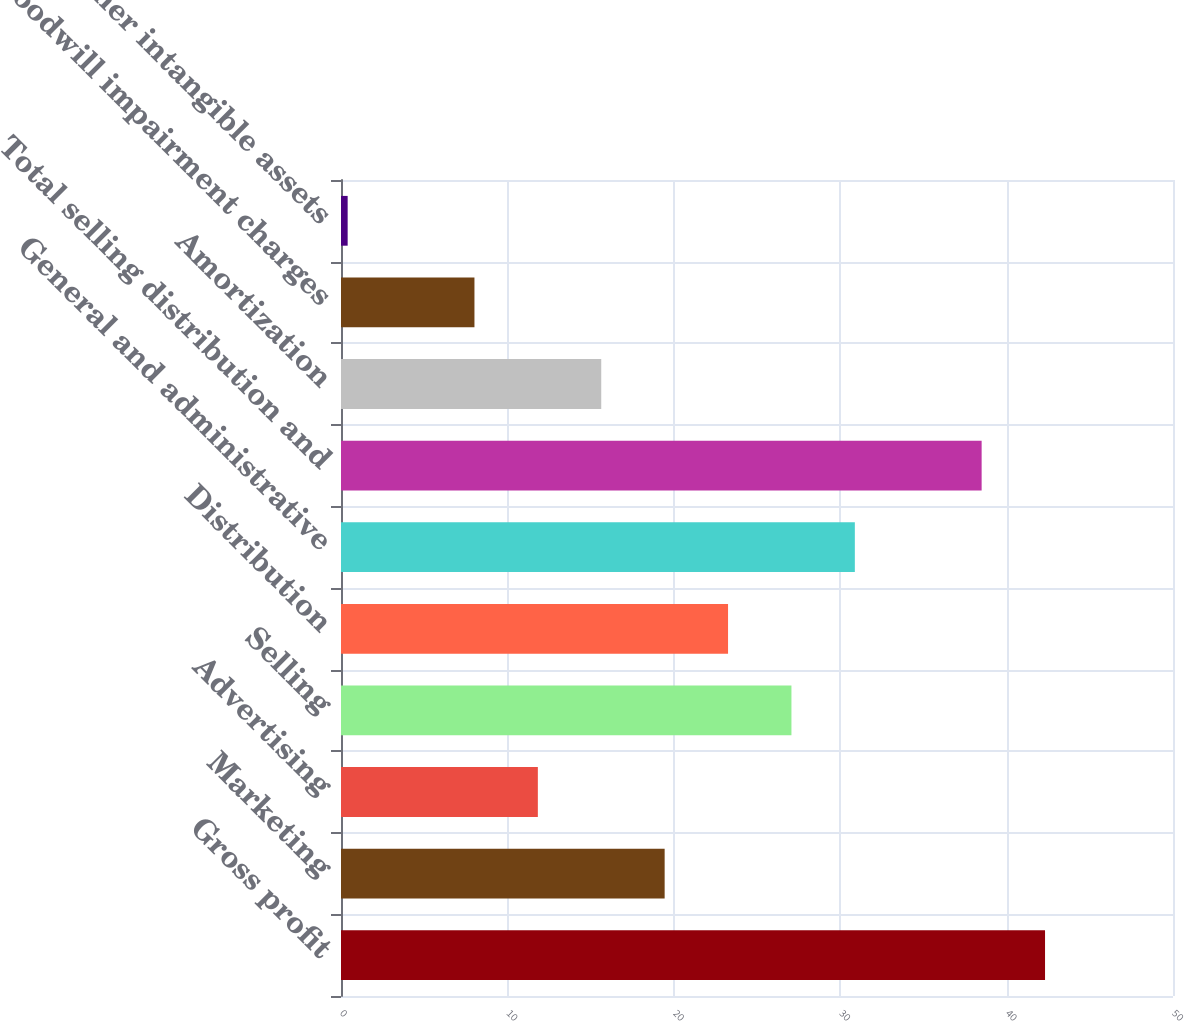<chart> <loc_0><loc_0><loc_500><loc_500><bar_chart><fcel>Gross profit<fcel>Marketing<fcel>Advertising<fcel>Selling<fcel>Distribution<fcel>General and administrative<fcel>Total selling distribution and<fcel>Amortization<fcel>Goodwill impairment charges<fcel>Other intangible assets<nl><fcel>42.31<fcel>19.45<fcel>11.83<fcel>27.07<fcel>23.26<fcel>30.88<fcel>38.5<fcel>15.64<fcel>8.02<fcel>0.4<nl></chart> 